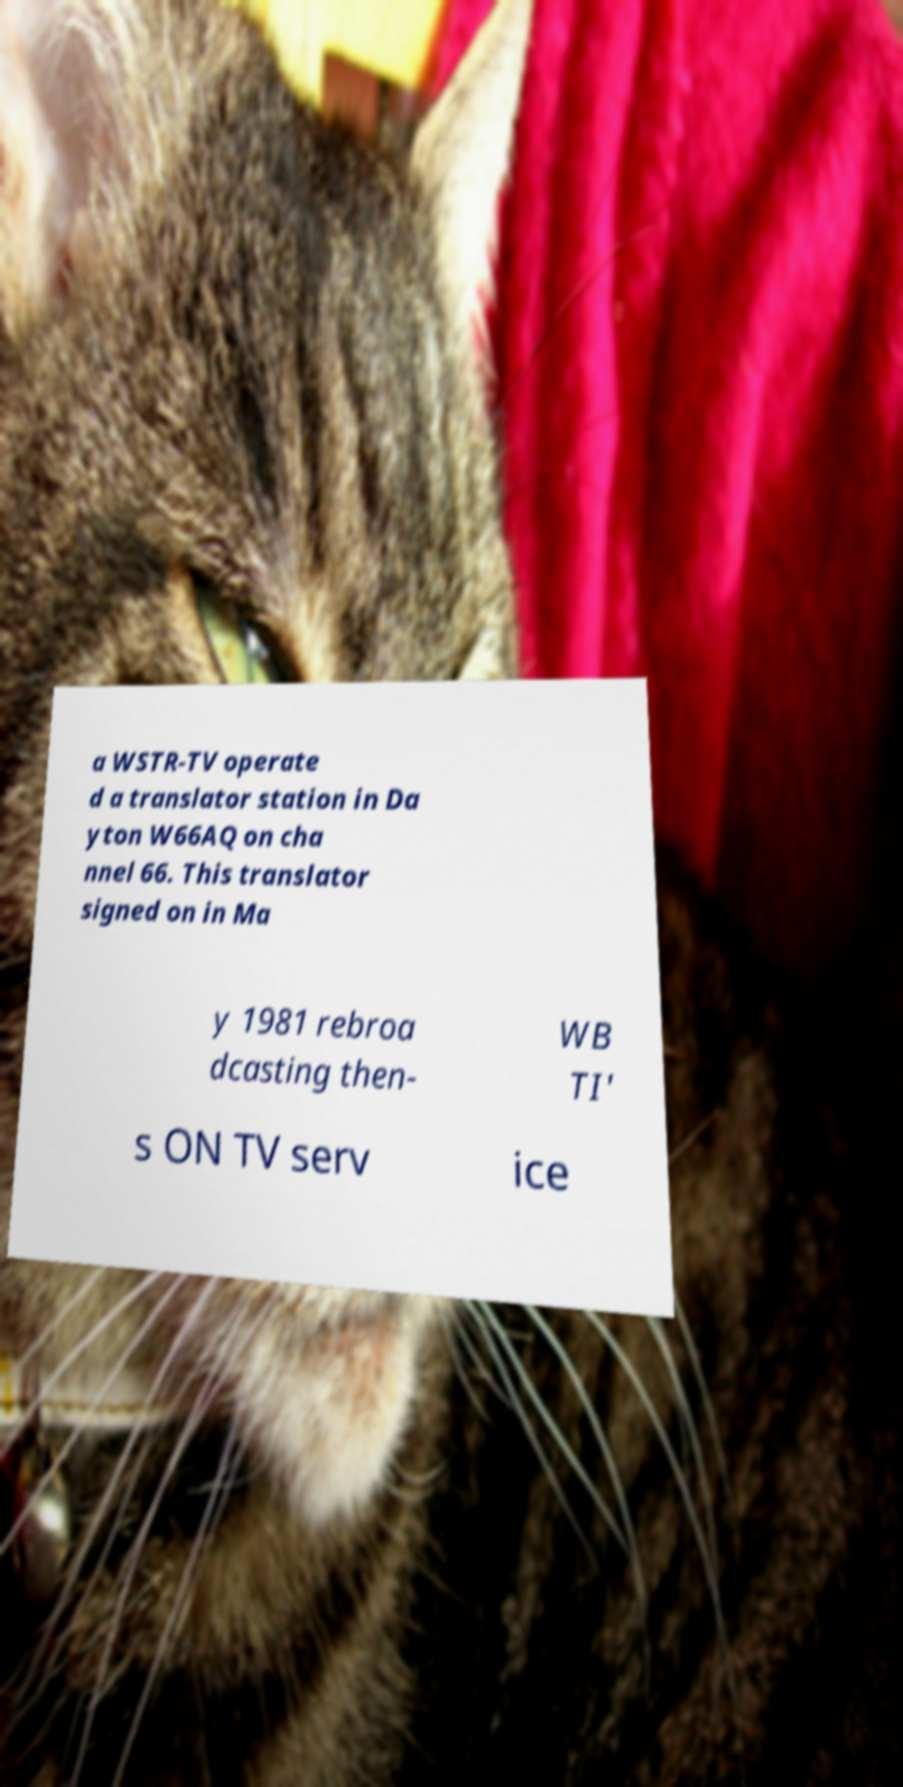Can you accurately transcribe the text from the provided image for me? a WSTR-TV operate d a translator station in Da yton W66AQ on cha nnel 66. This translator signed on in Ma y 1981 rebroa dcasting then- WB TI' s ON TV serv ice 